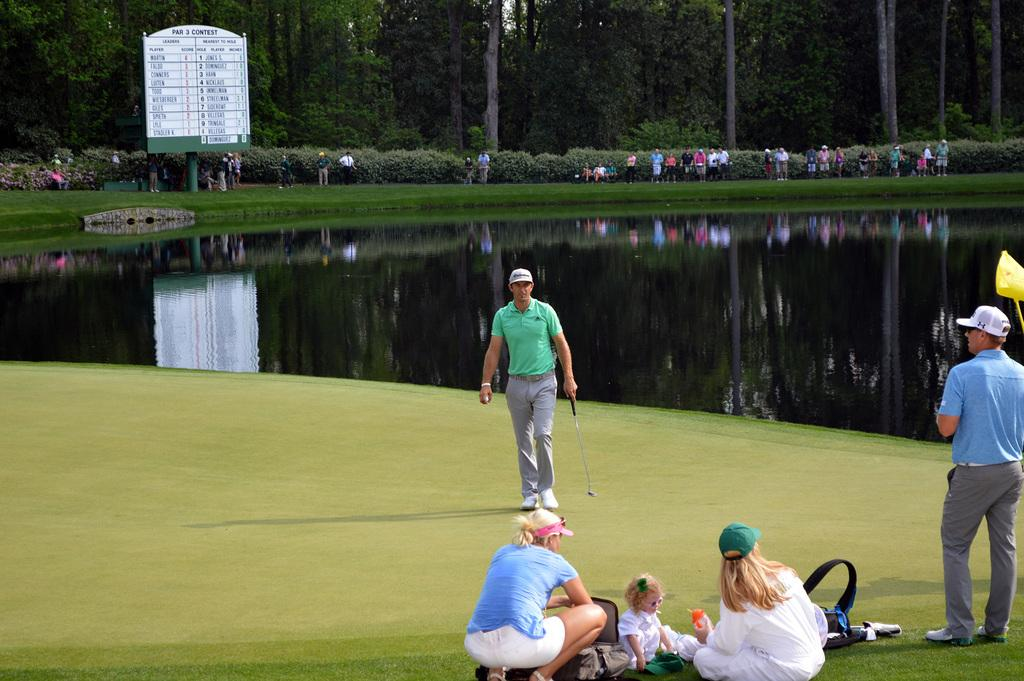What type of surface can be seen in the image? There is ground visible in the image. Who or what is present in the image? There are people in the image. What type of vegetation is present in the image? There are plants and trees in the image. What is the board with text used for in the image? The board with text is likely used for communication or information purposes. What natural element is visible in the image? There is water visible in the image. What type of crowd can be seen gathering around the need in the image? There is no mention of a need or a crowd gathering around it in the image. The image features people, plants, trees, water, and a board with text, but no need or crowd. 